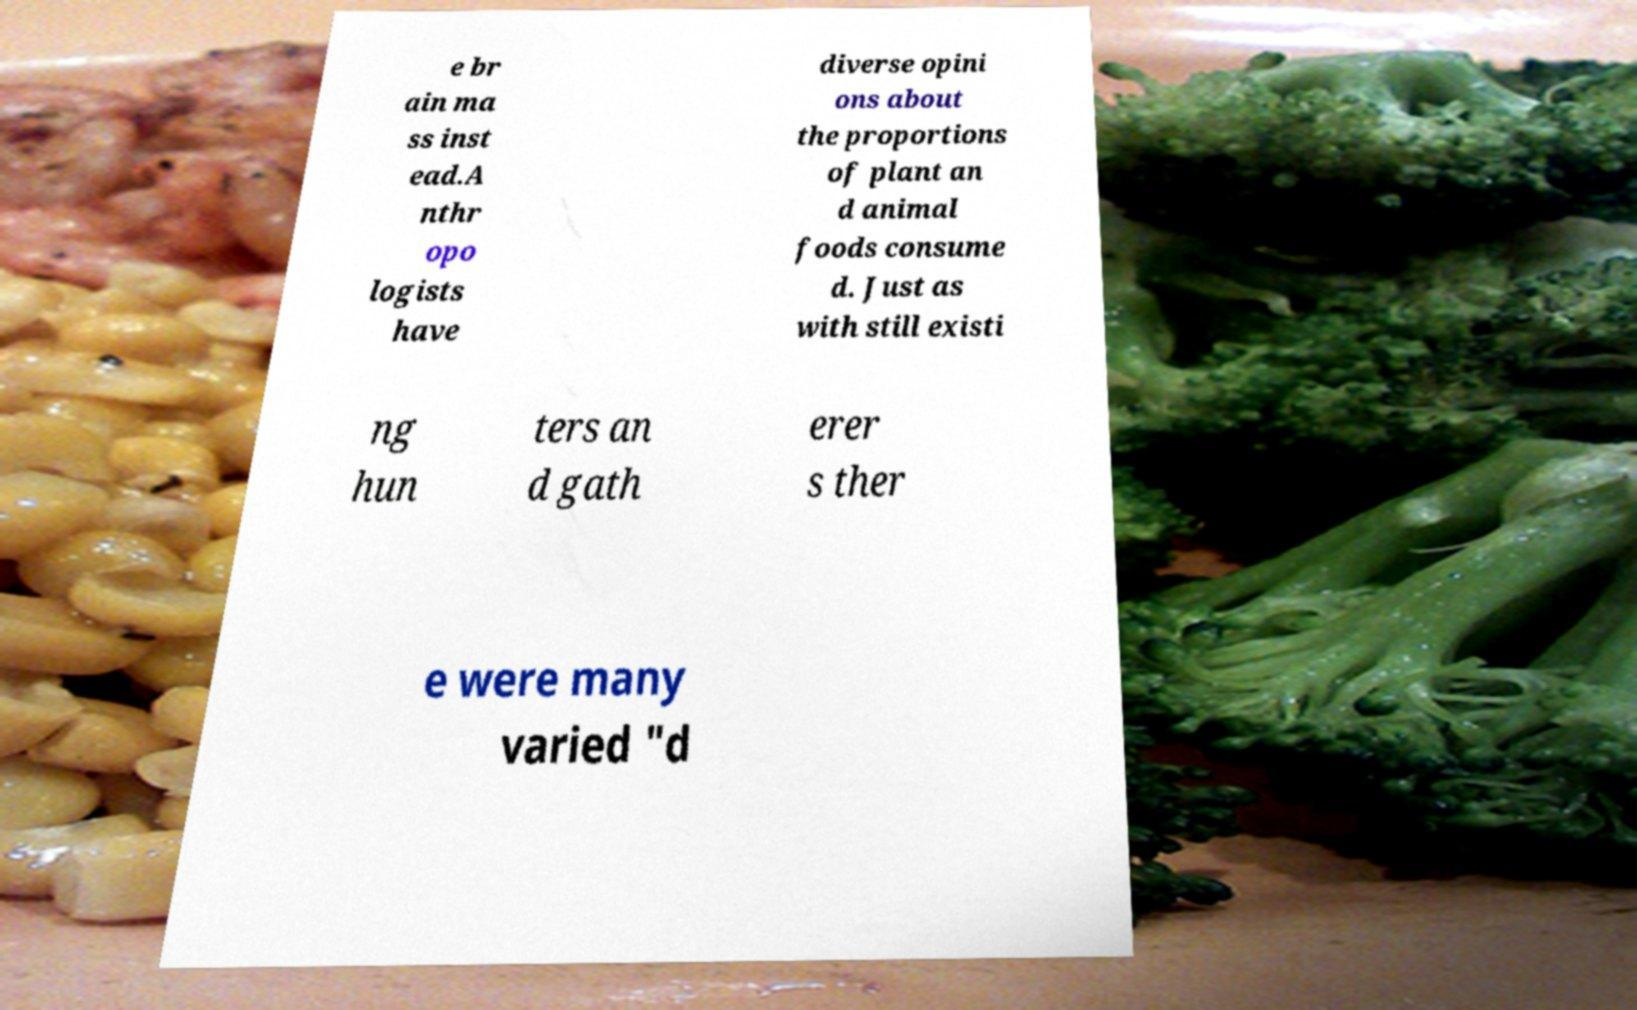Can you accurately transcribe the text from the provided image for me? e br ain ma ss inst ead.A nthr opo logists have diverse opini ons about the proportions of plant an d animal foods consume d. Just as with still existi ng hun ters an d gath erer s ther e were many varied "d 